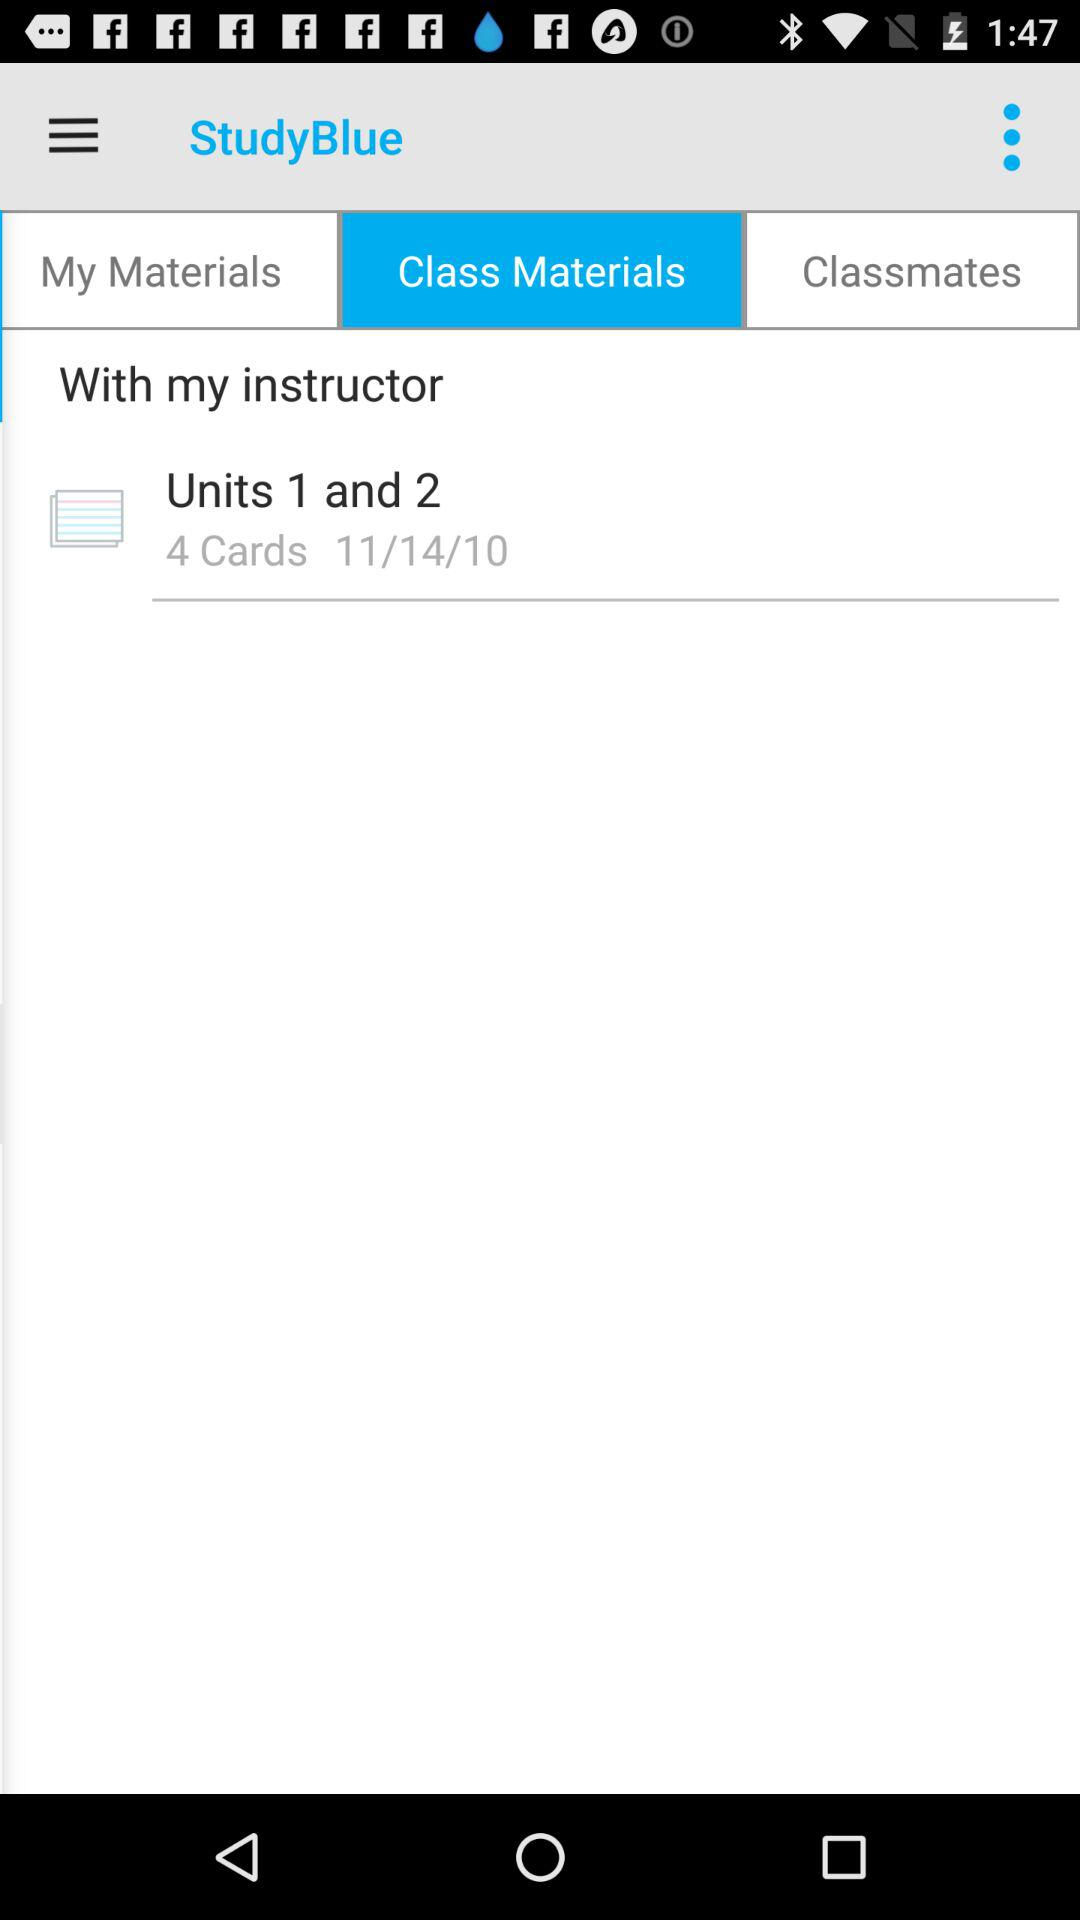How many cards are in the stack?
Answer the question using a single word or phrase. 4 